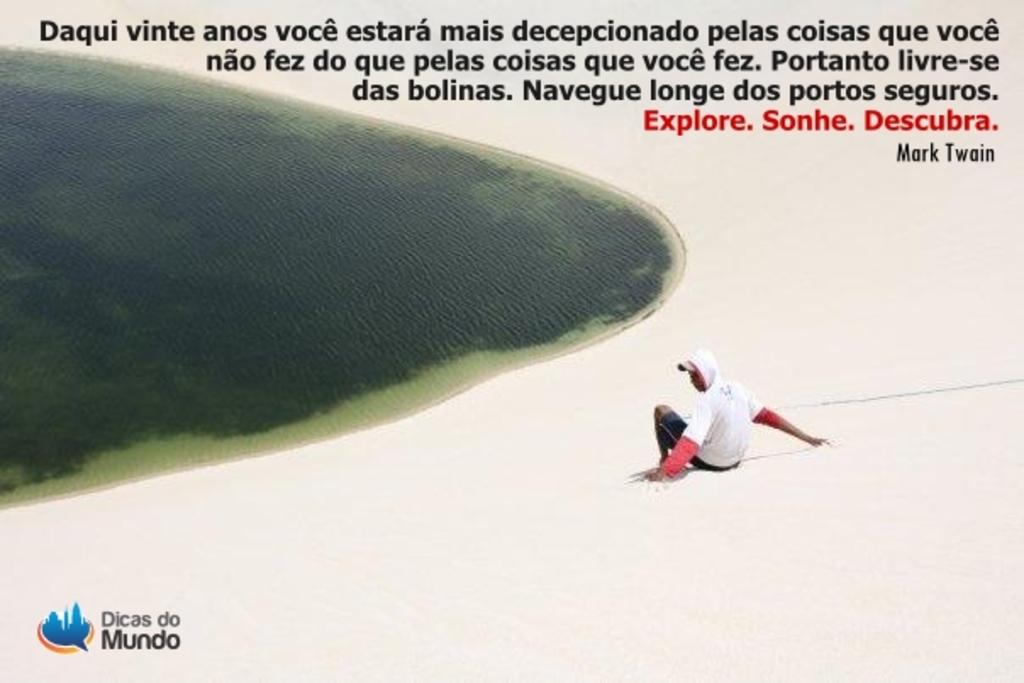<image>
Provide a brief description of the given image. A Spanish quote by Mark Twain has one line written in red lettering. 